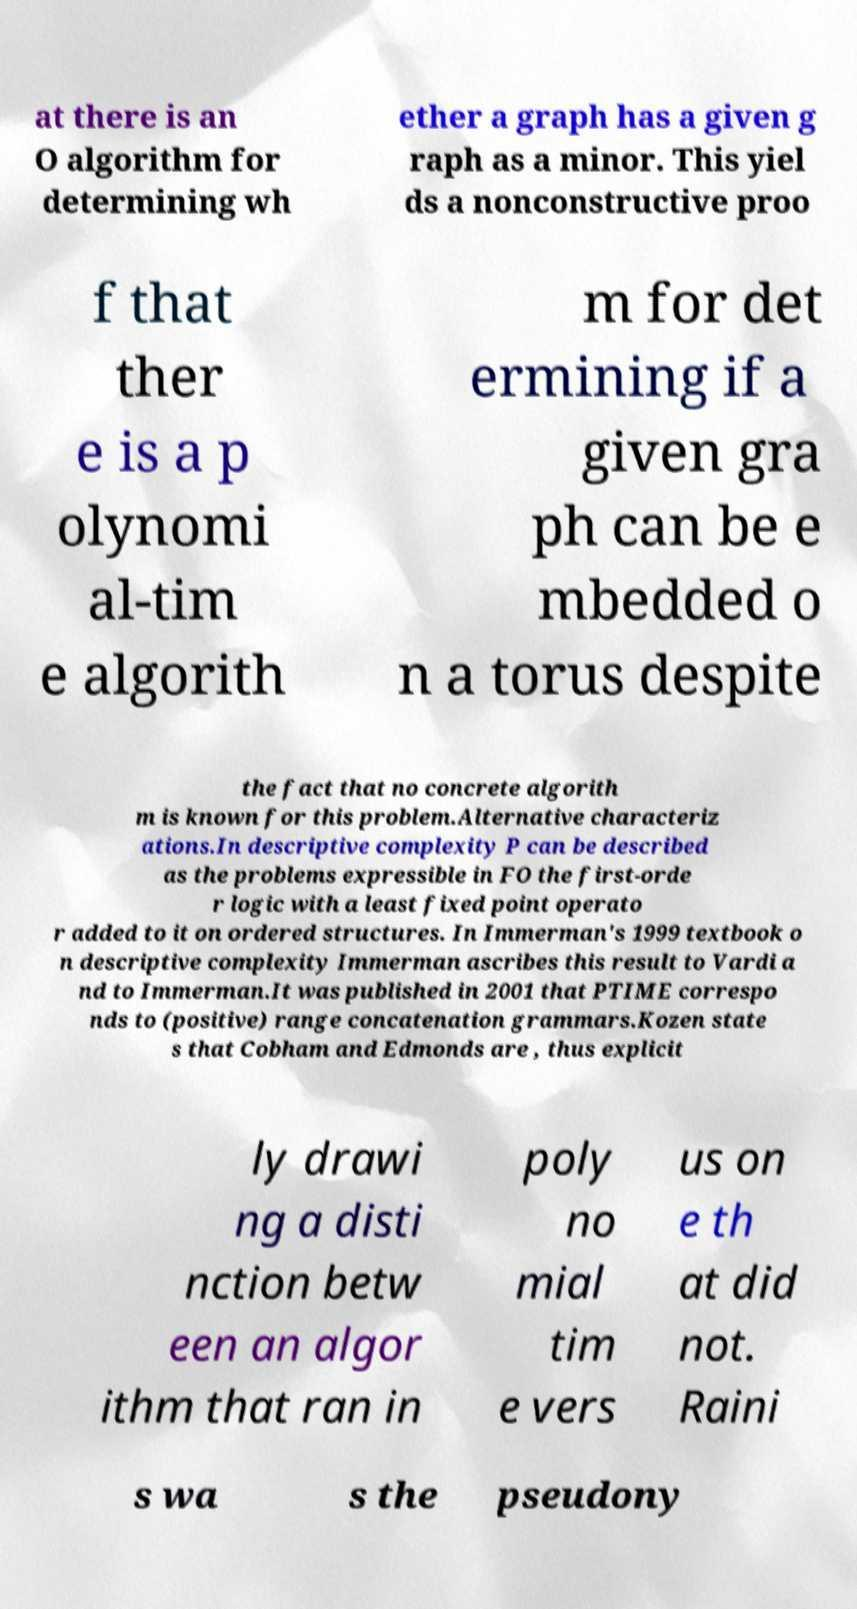Can you accurately transcribe the text from the provided image for me? at there is an O algorithm for determining wh ether a graph has a given g raph as a minor. This yiel ds a nonconstructive proo f that ther e is a p olynomi al-tim e algorith m for det ermining if a given gra ph can be e mbedded o n a torus despite the fact that no concrete algorith m is known for this problem.Alternative characteriz ations.In descriptive complexity P can be described as the problems expressible in FO the first-orde r logic with a least fixed point operato r added to it on ordered structures. In Immerman's 1999 textbook o n descriptive complexity Immerman ascribes this result to Vardi a nd to Immerman.It was published in 2001 that PTIME correspo nds to (positive) range concatenation grammars.Kozen state s that Cobham and Edmonds are , thus explicit ly drawi ng a disti nction betw een an algor ithm that ran in poly no mial tim e vers us on e th at did not. Raini s wa s the pseudony 